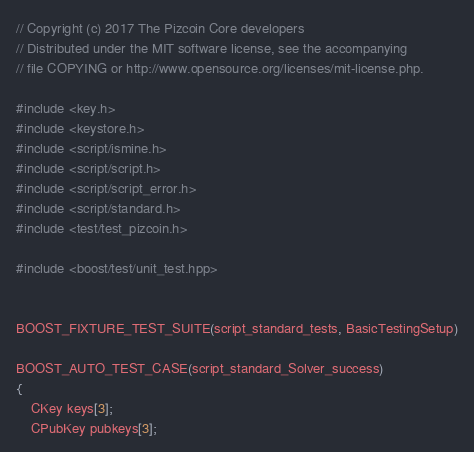<code> <loc_0><loc_0><loc_500><loc_500><_C++_>// Copyright (c) 2017 The Pizcoin Core developers
// Distributed under the MIT software license, see the accompanying
// file COPYING or http://www.opensource.org/licenses/mit-license.php.

#include <key.h>
#include <keystore.h>
#include <script/ismine.h>
#include <script/script.h>
#include <script/script_error.h>
#include <script/standard.h>
#include <test/test_pizcoin.h>

#include <boost/test/unit_test.hpp>


BOOST_FIXTURE_TEST_SUITE(script_standard_tests, BasicTestingSetup)

BOOST_AUTO_TEST_CASE(script_standard_Solver_success)
{
    CKey keys[3];
    CPubKey pubkeys[3];</code> 